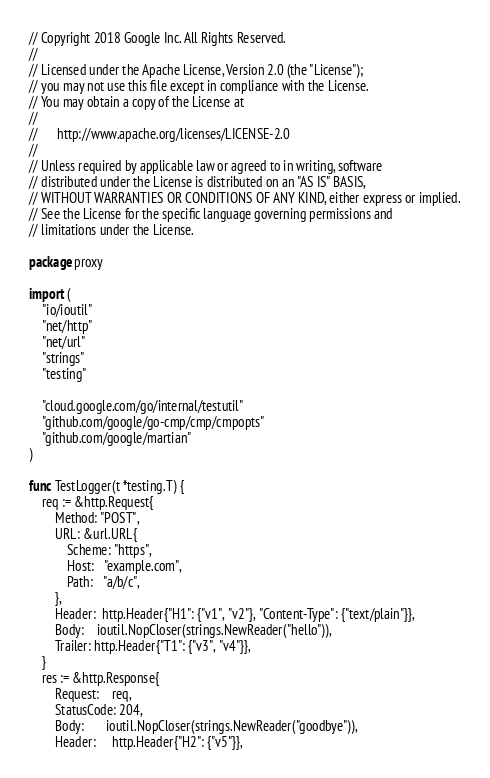<code> <loc_0><loc_0><loc_500><loc_500><_Go_>// Copyright 2018 Google Inc. All Rights Reserved.
//
// Licensed under the Apache License, Version 2.0 (the "License");
// you may not use this file except in compliance with the License.
// You may obtain a copy of the License at
//
//      http://www.apache.org/licenses/LICENSE-2.0
//
// Unless required by applicable law or agreed to in writing, software
// distributed under the License is distributed on an "AS IS" BASIS,
// WITHOUT WARRANTIES OR CONDITIONS OF ANY KIND, either express or implied.
// See the License for the specific language governing permissions and
// limitations under the License.

package proxy

import (
	"io/ioutil"
	"net/http"
	"net/url"
	"strings"
	"testing"

	"cloud.google.com/go/internal/testutil"
	"github.com/google/go-cmp/cmp/cmpopts"
	"github.com/google/martian"
)

func TestLogger(t *testing.T) {
	req := &http.Request{
		Method: "POST",
		URL: &url.URL{
			Scheme: "https",
			Host:   "example.com",
			Path:   "a/b/c",
		},
		Header:  http.Header{"H1": {"v1", "v2"}, "Content-Type": {"text/plain"}},
		Body:    ioutil.NopCloser(strings.NewReader("hello")),
		Trailer: http.Header{"T1": {"v3", "v4"}},
	}
	res := &http.Response{
		Request:    req,
		StatusCode: 204,
		Body:       ioutil.NopCloser(strings.NewReader("goodbye")),
		Header:     http.Header{"H2": {"v5"}},</code> 